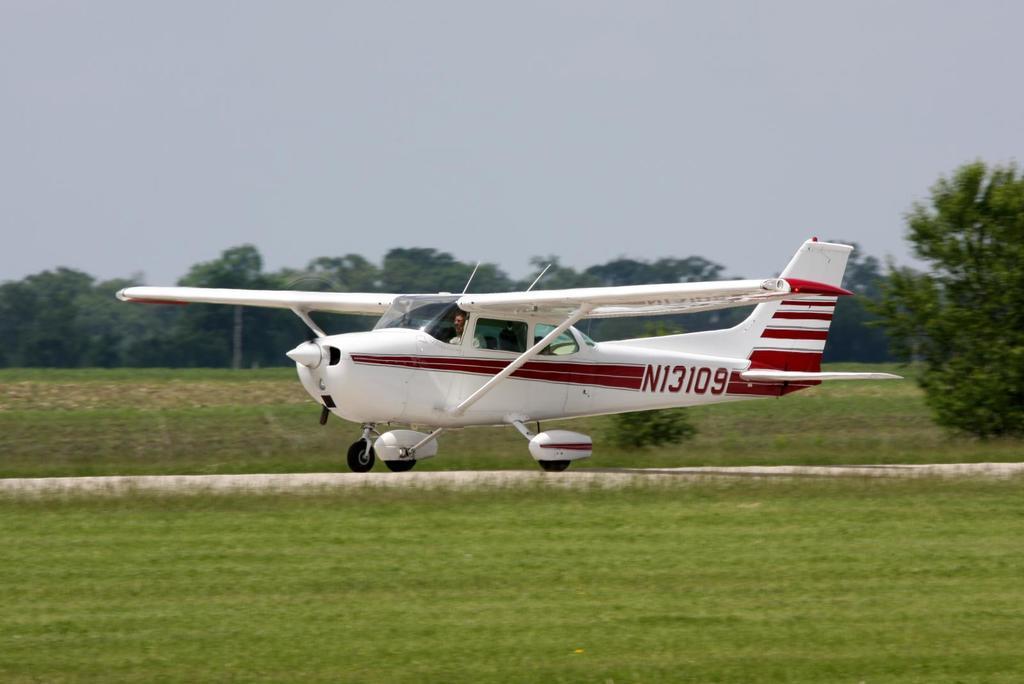Can you describe this image briefly? There is an airplane on the ground. Here we can see grass and trees. In the background there is sky. 